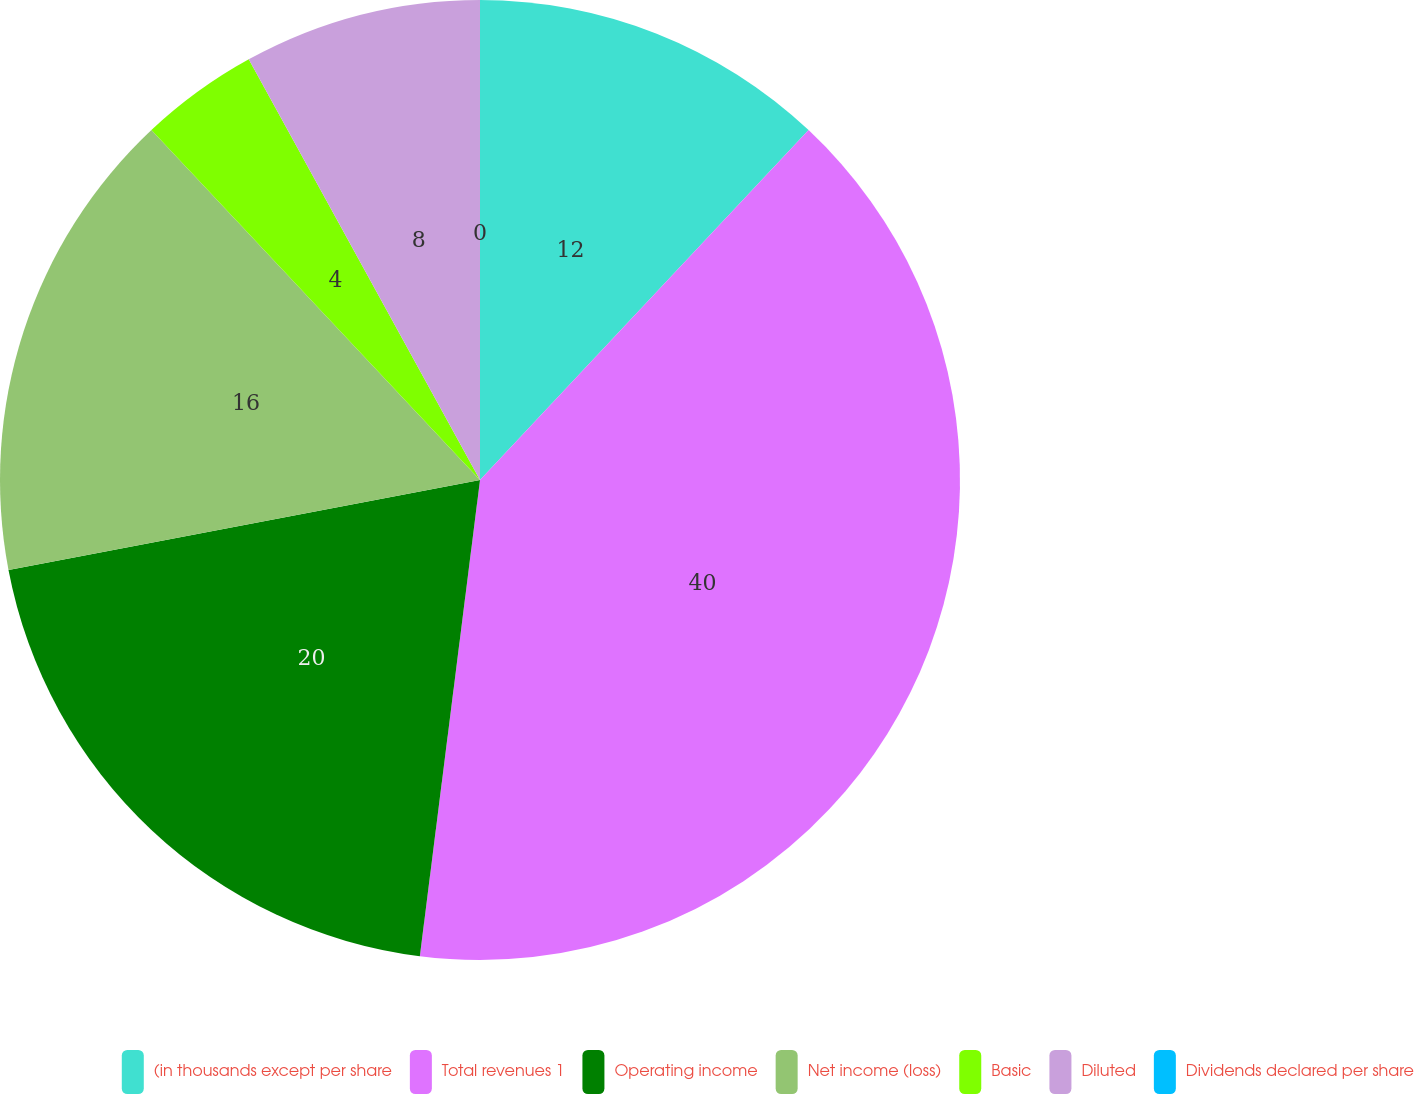Convert chart to OTSL. <chart><loc_0><loc_0><loc_500><loc_500><pie_chart><fcel>(in thousands except per share<fcel>Total revenues 1<fcel>Operating income<fcel>Net income (loss)<fcel>Basic<fcel>Diluted<fcel>Dividends declared per share<nl><fcel>12.0%<fcel>40.0%<fcel>20.0%<fcel>16.0%<fcel>4.0%<fcel>8.0%<fcel>0.0%<nl></chart> 